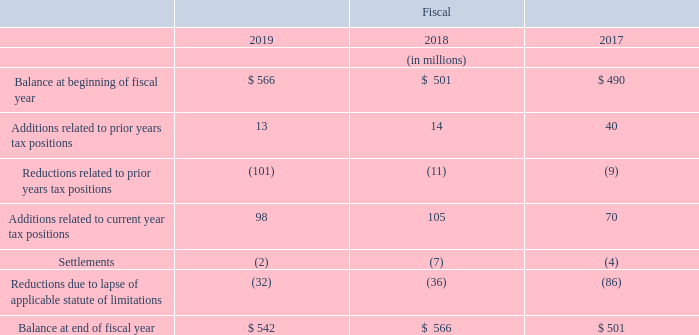Uncertain Tax Positions
As of fiscal year end 2019, we had total unrecognized income tax benefits of $542 million. If recognized in future years, $397 million of these currently unrecognized income tax benefits would impact income tax expense (benefit) and the effective tax rate. As of fiscal year end 2018, we had total unrecognized income tax benefits of $566 million. If recognized in future years, $467 million of these currently unrecognized income tax benefits would impact income tax expense (benefit) and the effective tax rate. The following table summarizes the activity related to unrecognized income tax benefits:
We record accrued interest and penalties related to uncertain tax positions as part of income tax expense (benefit). As of fiscal year end 2019 and 2018, we had $42 million and $60 million, respectively, of accrued interest and penalties related to uncertain tax positions on the Consolidated Balance Sheets, recorded primarily in income taxes. During fiscal 2019, 2018, and 2017, we recognized income tax benefits of $14 million, expense of $5 million, and benefits of $5 million, respectively, related to interest and penalties on the Consolidated Statements of Operations.
We file income tax returns on a unitary, consolidated, or stand-alone basis in multiple state and local jurisdictions, which generally have statutes of limitations ranging from 3 to 4 years. Various state and local income tax returns are currently in the process of examination or administrative appeal.
Our non-U.S. subsidiaries file income tax returns in the countries in which they have operations. Generally, these countries have statutes of limitations ranging from 3 to 10 years. Various non-U.S. subsidiary income tax returns are currently in the process of examination by taxing authorities.
What was the total unrecognized income tax benefits at the end of 2019? $542 million. Where does the non-U.S. subsidiaries file income tax returns in? In the countries in which they have operations. In which years are the total unrecognized income tax benefits calculated for? 2019, 2018, 2017. Which year were the Additions related to prior years tax positions the largest? 40>14>13
Answer: 2017. What was the change in the Additions related to prior years tax positions in 2019 from 2018?
Answer scale should be: million. 13-14
Answer: -1. What was the percentage change in the Additions related to prior years tax positions in 2019 from 2018?
Answer scale should be: percent. (13-14)/14
Answer: -7.14. 